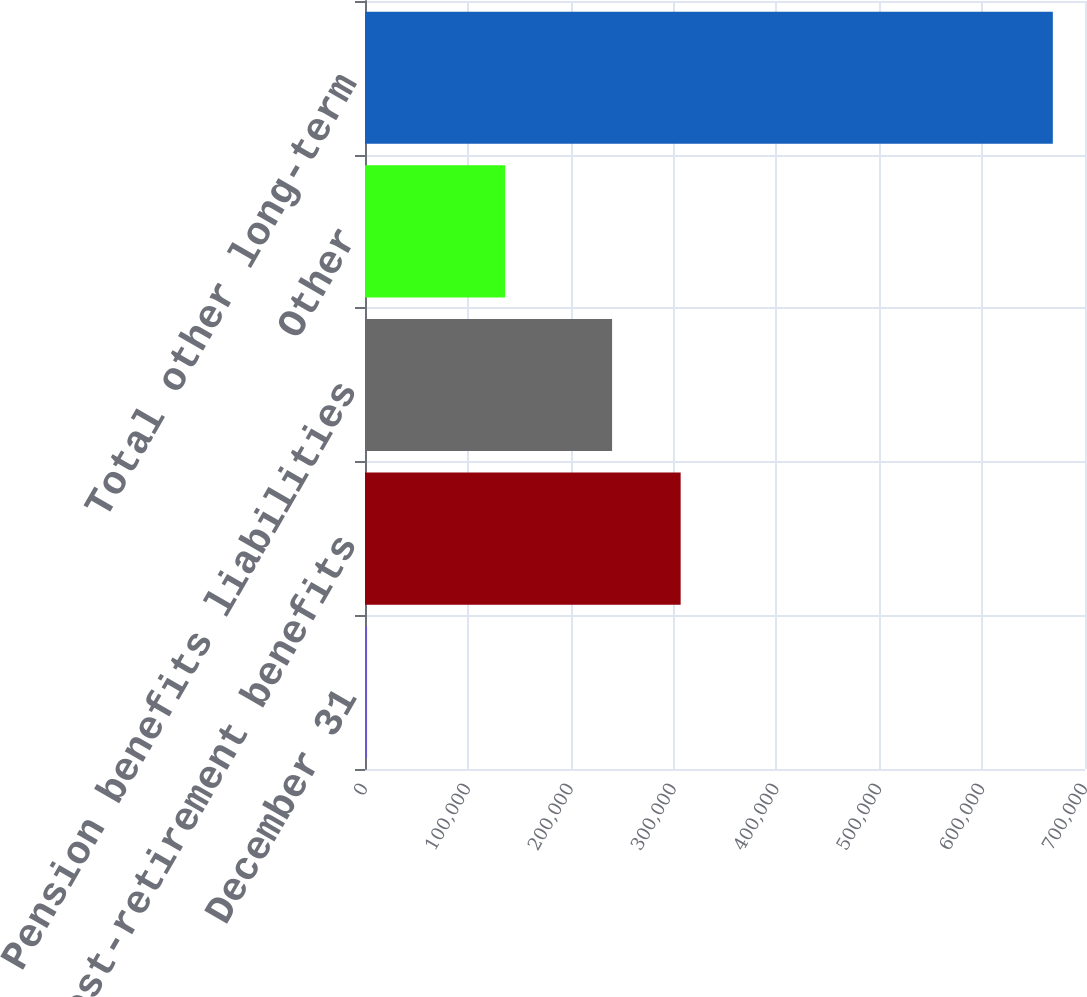Convert chart to OTSL. <chart><loc_0><loc_0><loc_500><loc_500><bar_chart><fcel>December 31<fcel>Post-retirement benefits<fcel>Pension benefits liabilities<fcel>Other<fcel>Total other long-term<nl><fcel>2012<fcel>306887<fcel>240215<fcel>136283<fcel>668732<nl></chart> 